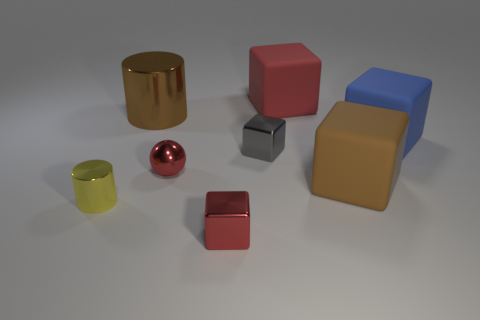Subtract 1 cubes. How many cubes are left? 4 Subtract all blue blocks. How many blocks are left? 4 Subtract all red metal blocks. How many blocks are left? 4 Subtract all green cubes. Subtract all yellow spheres. How many cubes are left? 5 Add 2 small red metallic objects. How many objects exist? 10 Subtract all cubes. How many objects are left? 3 Subtract 0 purple cubes. How many objects are left? 8 Subtract all rubber cubes. Subtract all small blue shiny cubes. How many objects are left? 5 Add 5 small red metal objects. How many small red metal objects are left? 7 Add 6 red matte objects. How many red matte objects exist? 7 